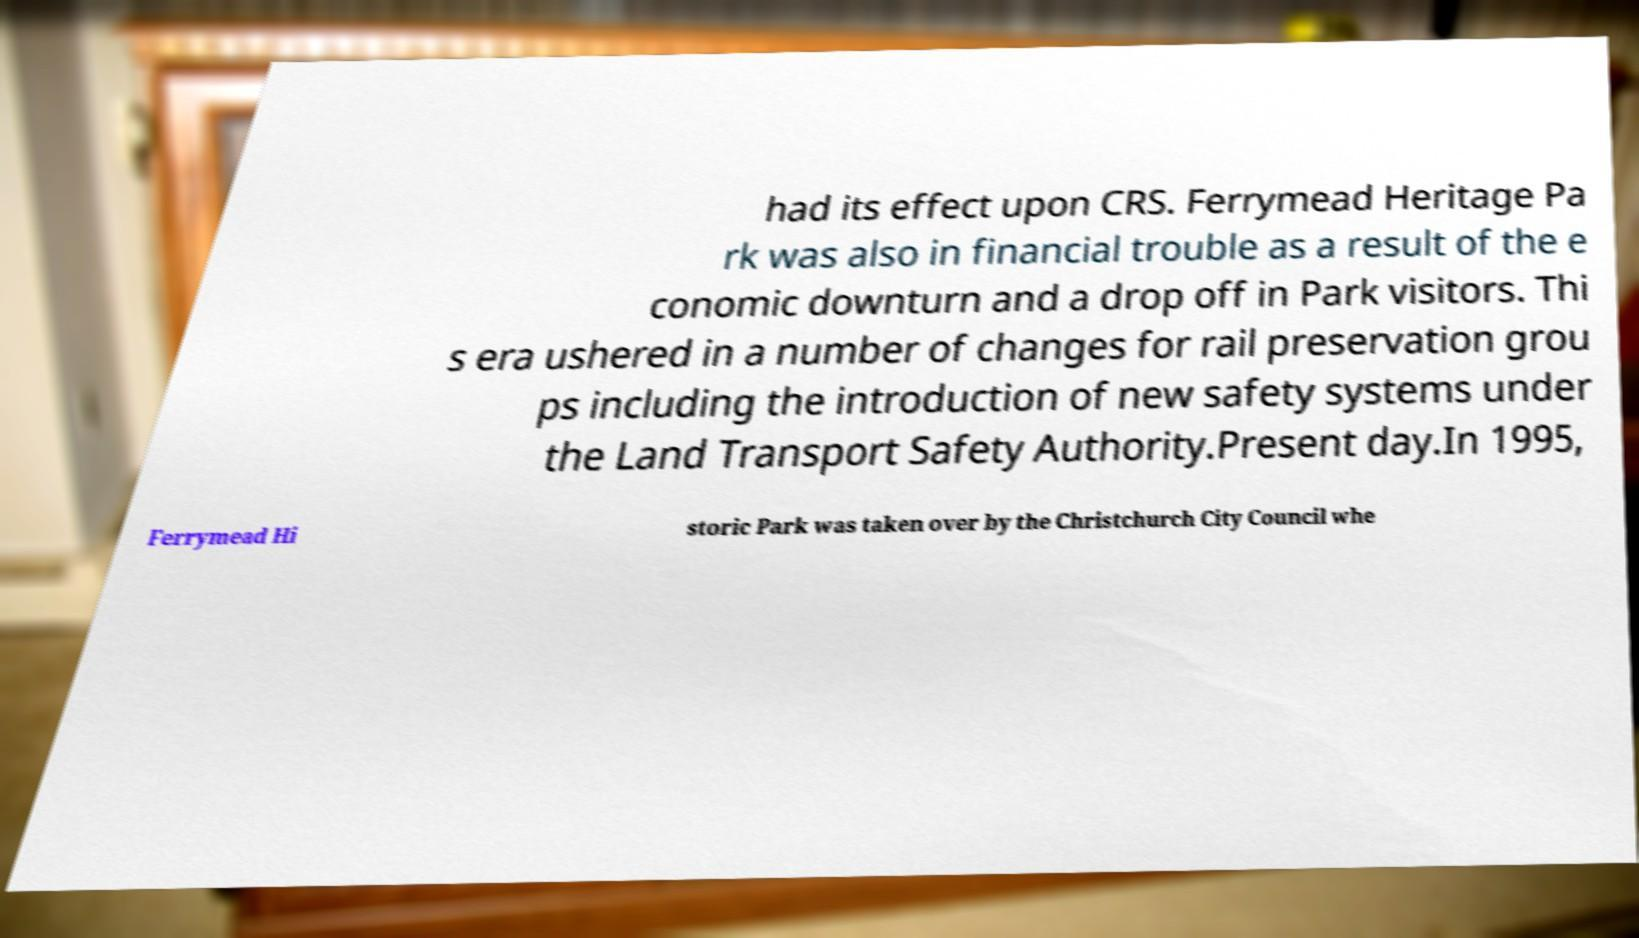Could you extract and type out the text from this image? had its effect upon CRS. Ferrymead Heritage Pa rk was also in financial trouble as a result of the e conomic downturn and a drop off in Park visitors. Thi s era ushered in a number of changes for rail preservation grou ps including the introduction of new safety systems under the Land Transport Safety Authority.Present day.In 1995, Ferrymead Hi storic Park was taken over by the Christchurch City Council whe 